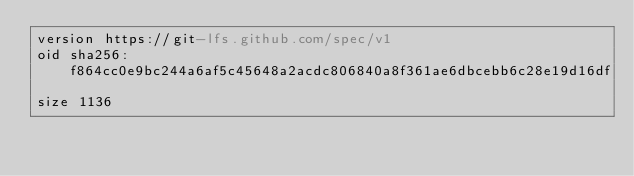Convert code to text. <code><loc_0><loc_0><loc_500><loc_500><_YAML_>version https://git-lfs.github.com/spec/v1
oid sha256:f864cc0e9bc244a6af5c45648a2acdc806840a8f361ae6dbcebb6c28e19d16df
size 1136
</code> 